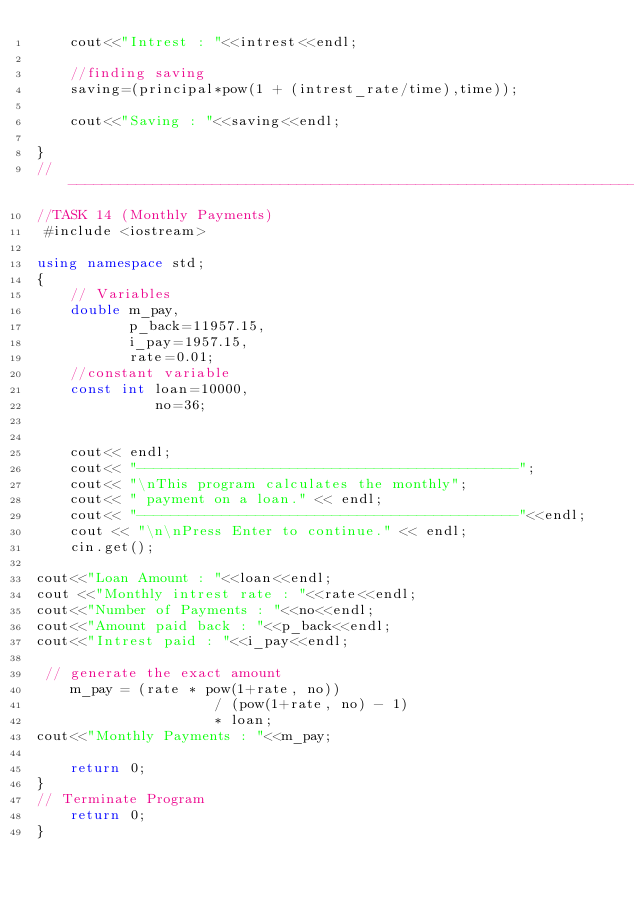Convert code to text. <code><loc_0><loc_0><loc_500><loc_500><_C++_>    cout<<"Intrest : "<<intrest<<endl;
    
    //finding saving
    saving=(principal*pow(1 + (intrest_rate/time),time));
    
    cout<<"Saving : "<<saving<<endl;
   
}
//--------------------------------------------------------------------------------------
//TASK 14 (Monthly Payments)
 #include <iostream>

using namespace std;
{
    // Variables
    double m_pay,
	       p_back=11957.15,
	       i_pay=1957.15,
		   rate=0.01;
    //constant variable 
    const int loan=10000,
              no=36;
              
    
    cout<< endl;
    cout<< "---------------------------------------------";
    cout<< "\nThis program calculates the monthly";
    cout<< " payment on a loan." << endl;
    cout<< "---------------------------------------------"<<endl;
    cout << "\n\nPress Enter to continue." << endl;
    cin.get();
    
cout<<"Loan Amount : "<<loan<<endl;
cout <<"Monthly intrest rate : "<<rate<<endl;
cout<<"Number of Payments : "<<no<<endl;
cout<<"Amount paid back : "<<p_back<<endl;
cout<<"Intrest paid : "<<i_pay<<endl;

 // generate the exact amount
	m_pay = (rate * pow(1+rate, no))
	                 / (pow(1+rate, no) - 1)
	                 * loan;
cout<<"Monthly Payments : "<<m_pay;
  
    return 0;
}
// Terminate Program
    return 0;
}
</code> 